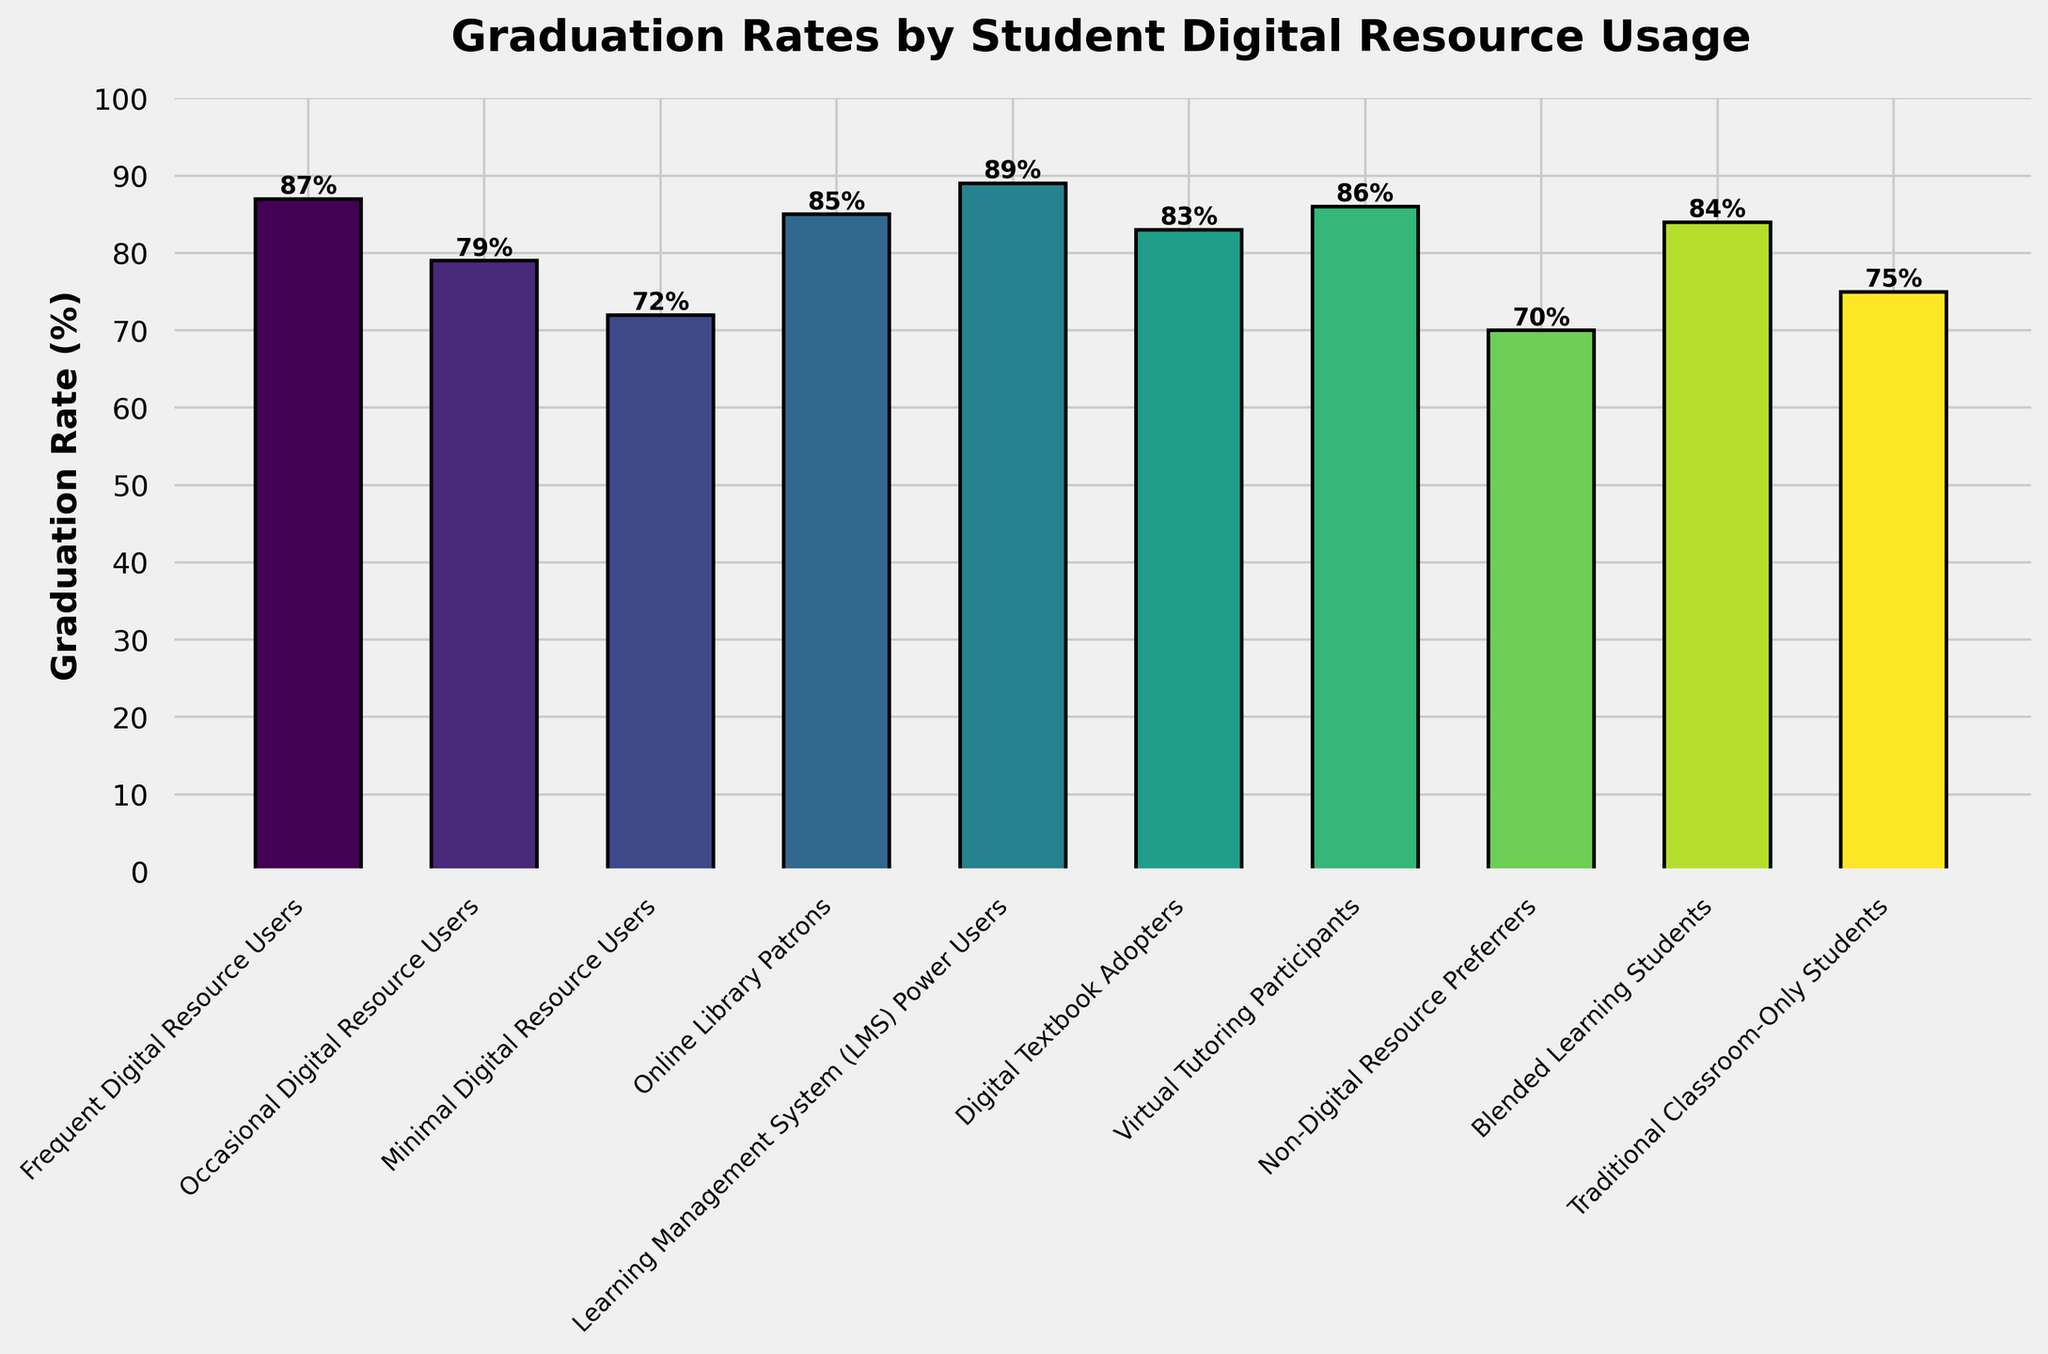What is the graduation rate for students who frequently use digital resources? Locate the bar labeled "Frequent Digital Resource Users;" its height corresponds to the graduation rate of 87%.
Answer: 87% Which group has the lowest graduation rate? Identify the shortest bar on the chart, which corresponds to the "Non-Digital Resource Preferrers." This group has a graduation rate of 70%.
Answer: Non-Digital Resource Preferrers What is the difference in graduation rates between Frequent Digital Resource Users and Traditional Classroom-Only Students? Find the height of both bars: Frequent Digital Resource Users (87%) and Traditional Classroom-Only Students (75%). Subtract the latter from the former (87% - 75% = 12%).
Answer: 12% Which group has a higher graduation rate: Digital Textbook Adopters or Online Library Patrons? Compare the heights of the bars for "Digital Textbook Adopters" (83%) and "Online Library Patrons" (85%). The latter is taller.
Answer: Online Library Patrons What is the average graduation rate of Blended Learning Students and Traditional Classroom-Only Students? Find the heights of the bars for "Blended Learning Students" (84%) and "Traditional Classroom-Only Students" (75%). Sum them (84% + 75% = 159%) and divide by 2 for the average ((84 + 75) / 2 = 79.5%).
Answer: 79.5% Are the graduation rates for Learning Management System (LMS) Power Users and Frequent Digital Resource Users close to each other? Observe the heights of the bars for "Learning Management System (LMS) Power Users" (89%) and "Frequent Digital Resource Users" (87%). The rates are very close, with a difference of only 2%.
Answer: Yes What is the sum of graduation rates for Virtual Tutoring Participants and Non-Digital Resource Preferrers? Add the heights of the bars for "Virtual Tutoring Participants" (86%) and "Non-Digital Resource Preferrers" (70%). Sum them (86% + 70% = 156%).
Answer: 156% How much higher is the graduation rate of Virtual Tutoring Participants compared to Minimal Digital Resource Users? Find the heights of the bars for both groups: "Virtual Tutoring Participants" (86%) and "Minimal Digital Resource Users" (72%). Subtract the latter from the former (86% - 72% = 14%).
Answer: 14% Which groups have a graduation rate higher than 80%? Locate all bars with heights greater than 80%. These groups are: Frequent Digital Resource Users (87%), Online Library Patrons (85%), Learning Management System (LMS) Power Users (89%), Digital Textbook Adopters (83%), Virtual Tutoring Participants (86%), and Blended Learning Students (84%).
Answer: Frequent Digital Resource Users, Online Library Patrons, Learning Management System (LMS) Power Users, Digital Textbook Adopters, Virtual Tutoring Participants, Blended Learning Students 